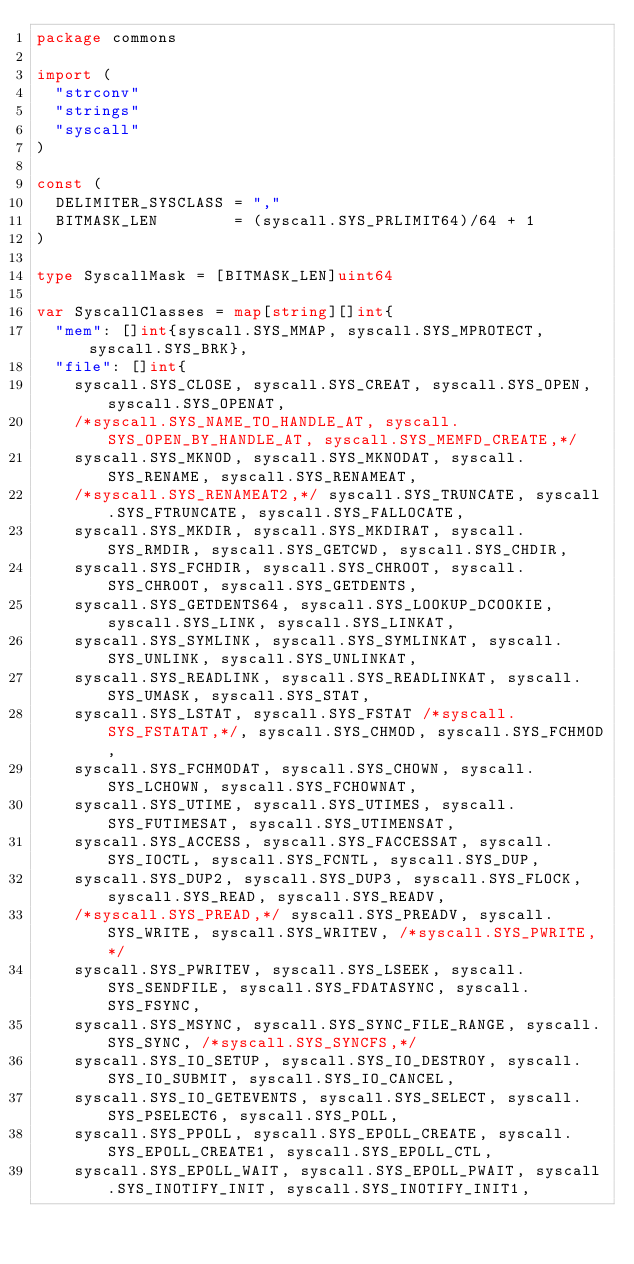Convert code to text. <code><loc_0><loc_0><loc_500><loc_500><_Go_>package commons

import (
	"strconv"
	"strings"
	"syscall"
)

const (
	DELIMITER_SYSCLASS = ","
	BITMASK_LEN        = (syscall.SYS_PRLIMIT64)/64 + 1
)

type SyscallMask = [BITMASK_LEN]uint64

var SyscallClasses = map[string][]int{
	"mem": []int{syscall.SYS_MMAP, syscall.SYS_MPROTECT, syscall.SYS_BRK},
	"file": []int{
		syscall.SYS_CLOSE, syscall.SYS_CREAT, syscall.SYS_OPEN, syscall.SYS_OPENAT,
		/*syscall.SYS_NAME_TO_HANDLE_AT, syscall.SYS_OPEN_BY_HANDLE_AT, syscall.SYS_MEMFD_CREATE,*/
		syscall.SYS_MKNOD, syscall.SYS_MKNODAT, syscall.SYS_RENAME, syscall.SYS_RENAMEAT,
		/*syscall.SYS_RENAMEAT2,*/ syscall.SYS_TRUNCATE, syscall.SYS_FTRUNCATE, syscall.SYS_FALLOCATE,
		syscall.SYS_MKDIR, syscall.SYS_MKDIRAT, syscall.SYS_RMDIR, syscall.SYS_GETCWD, syscall.SYS_CHDIR,
		syscall.SYS_FCHDIR, syscall.SYS_CHROOT, syscall.SYS_CHROOT, syscall.SYS_GETDENTS,
		syscall.SYS_GETDENTS64, syscall.SYS_LOOKUP_DCOOKIE, syscall.SYS_LINK, syscall.SYS_LINKAT,
		syscall.SYS_SYMLINK, syscall.SYS_SYMLINKAT, syscall.SYS_UNLINK, syscall.SYS_UNLINKAT,
		syscall.SYS_READLINK, syscall.SYS_READLINKAT, syscall.SYS_UMASK, syscall.SYS_STAT,
		syscall.SYS_LSTAT, syscall.SYS_FSTAT /*syscall.SYS_FSTATAT,*/, syscall.SYS_CHMOD, syscall.SYS_FCHMOD,
		syscall.SYS_FCHMODAT, syscall.SYS_CHOWN, syscall.SYS_LCHOWN, syscall.SYS_FCHOWNAT,
		syscall.SYS_UTIME, syscall.SYS_UTIMES, syscall.SYS_FUTIMESAT, syscall.SYS_UTIMENSAT,
		syscall.SYS_ACCESS, syscall.SYS_FACCESSAT, syscall.SYS_IOCTL, syscall.SYS_FCNTL, syscall.SYS_DUP,
		syscall.SYS_DUP2, syscall.SYS_DUP3, syscall.SYS_FLOCK, syscall.SYS_READ, syscall.SYS_READV,
		/*syscall.SYS_PREAD,*/ syscall.SYS_PREADV, syscall.SYS_WRITE, syscall.SYS_WRITEV, /*syscall.SYS_PWRITE,*/
		syscall.SYS_PWRITEV, syscall.SYS_LSEEK, syscall.SYS_SENDFILE, syscall.SYS_FDATASYNC, syscall.SYS_FSYNC,
		syscall.SYS_MSYNC, syscall.SYS_SYNC_FILE_RANGE, syscall.SYS_SYNC, /*syscall.SYS_SYNCFS,*/
		syscall.SYS_IO_SETUP, syscall.SYS_IO_DESTROY, syscall.SYS_IO_SUBMIT, syscall.SYS_IO_CANCEL,
		syscall.SYS_IO_GETEVENTS, syscall.SYS_SELECT, syscall.SYS_PSELECT6, syscall.SYS_POLL,
		syscall.SYS_PPOLL, syscall.SYS_EPOLL_CREATE, syscall.SYS_EPOLL_CREATE1, syscall.SYS_EPOLL_CTL,
		syscall.SYS_EPOLL_WAIT, syscall.SYS_EPOLL_PWAIT, syscall.SYS_INOTIFY_INIT, syscall.SYS_INOTIFY_INIT1,</code> 